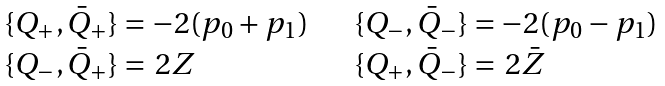<formula> <loc_0><loc_0><loc_500><loc_500>\begin{array} { l l } \{ Q _ { + } , \bar { Q } _ { + } \} = - 2 ( p _ { 0 } + p _ { 1 } ) \quad & \{ Q _ { - } , \bar { Q } _ { - } \} = - 2 ( p _ { 0 } - p _ { 1 } ) \\ \{ Q _ { - } , \bar { Q } _ { + } \} = \, 2 Z & \{ Q _ { + } , \bar { Q } _ { - } \} = \, 2 \bar { Z } \\ \end{array}</formula> 